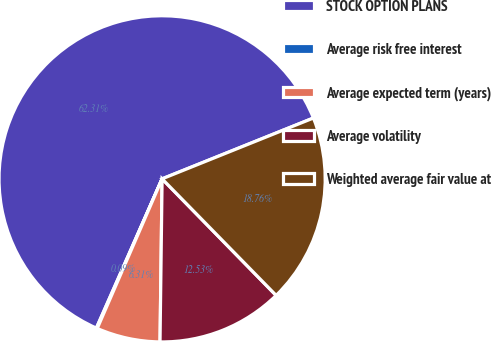Convert chart. <chart><loc_0><loc_0><loc_500><loc_500><pie_chart><fcel>STOCK OPTION PLANS<fcel>Average risk free interest<fcel>Average expected term (years)<fcel>Average volatility<fcel>Weighted average fair value at<nl><fcel>62.32%<fcel>0.09%<fcel>6.31%<fcel>12.53%<fcel>18.76%<nl></chart> 